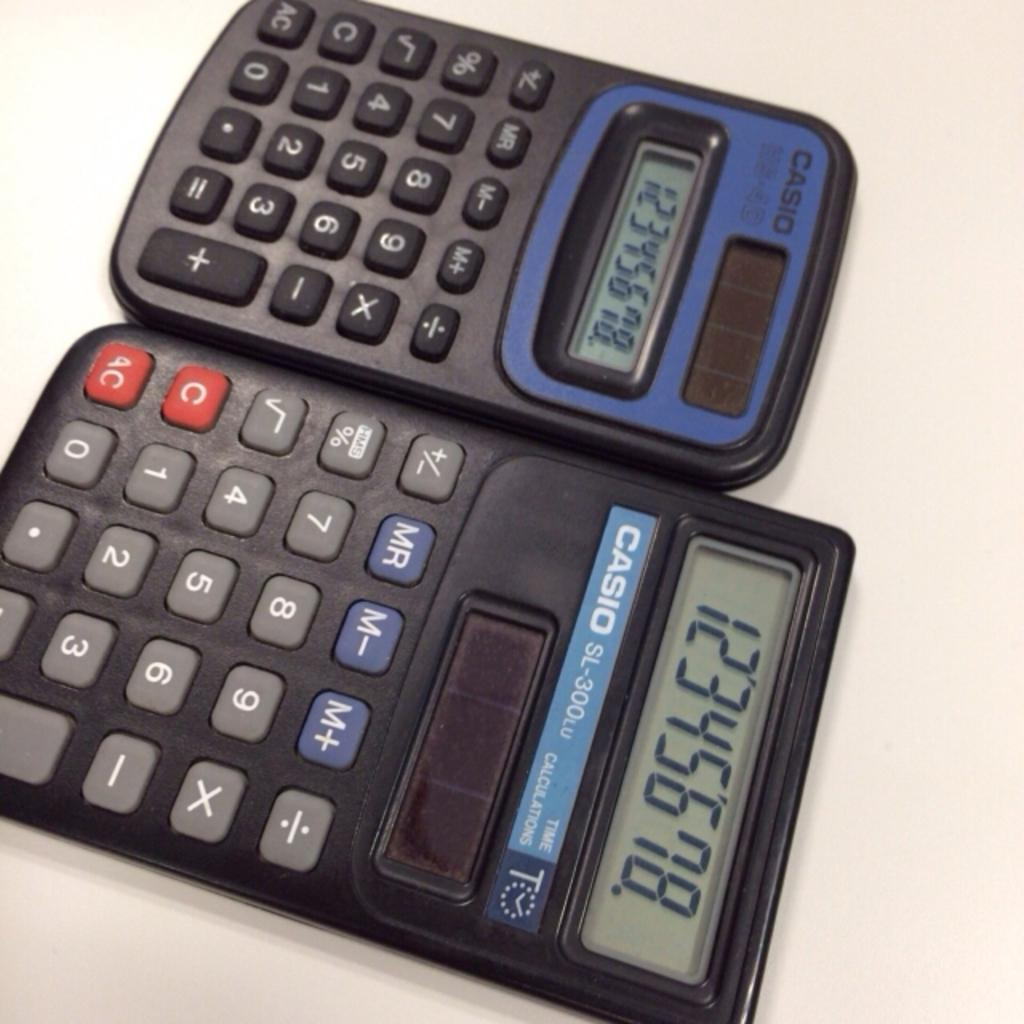<image>
Describe the image concisely. two calculators next to one another by the brand 'casio' 